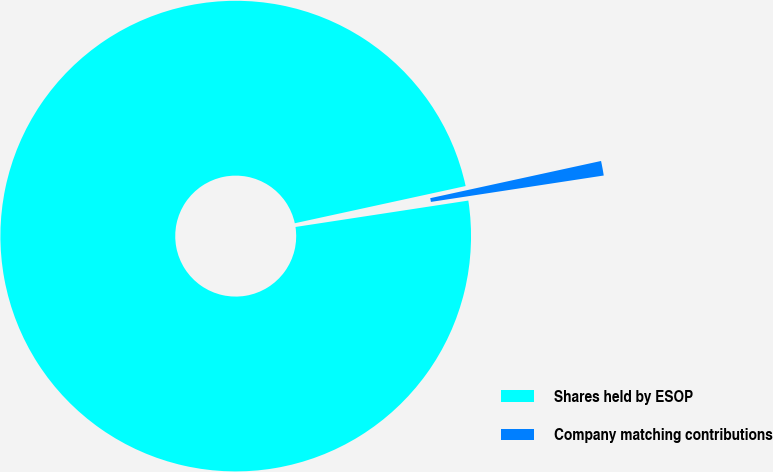Convert chart to OTSL. <chart><loc_0><loc_0><loc_500><loc_500><pie_chart><fcel>Shares held by ESOP<fcel>Company matching contributions<nl><fcel>99.0%<fcel>1.0%<nl></chart> 